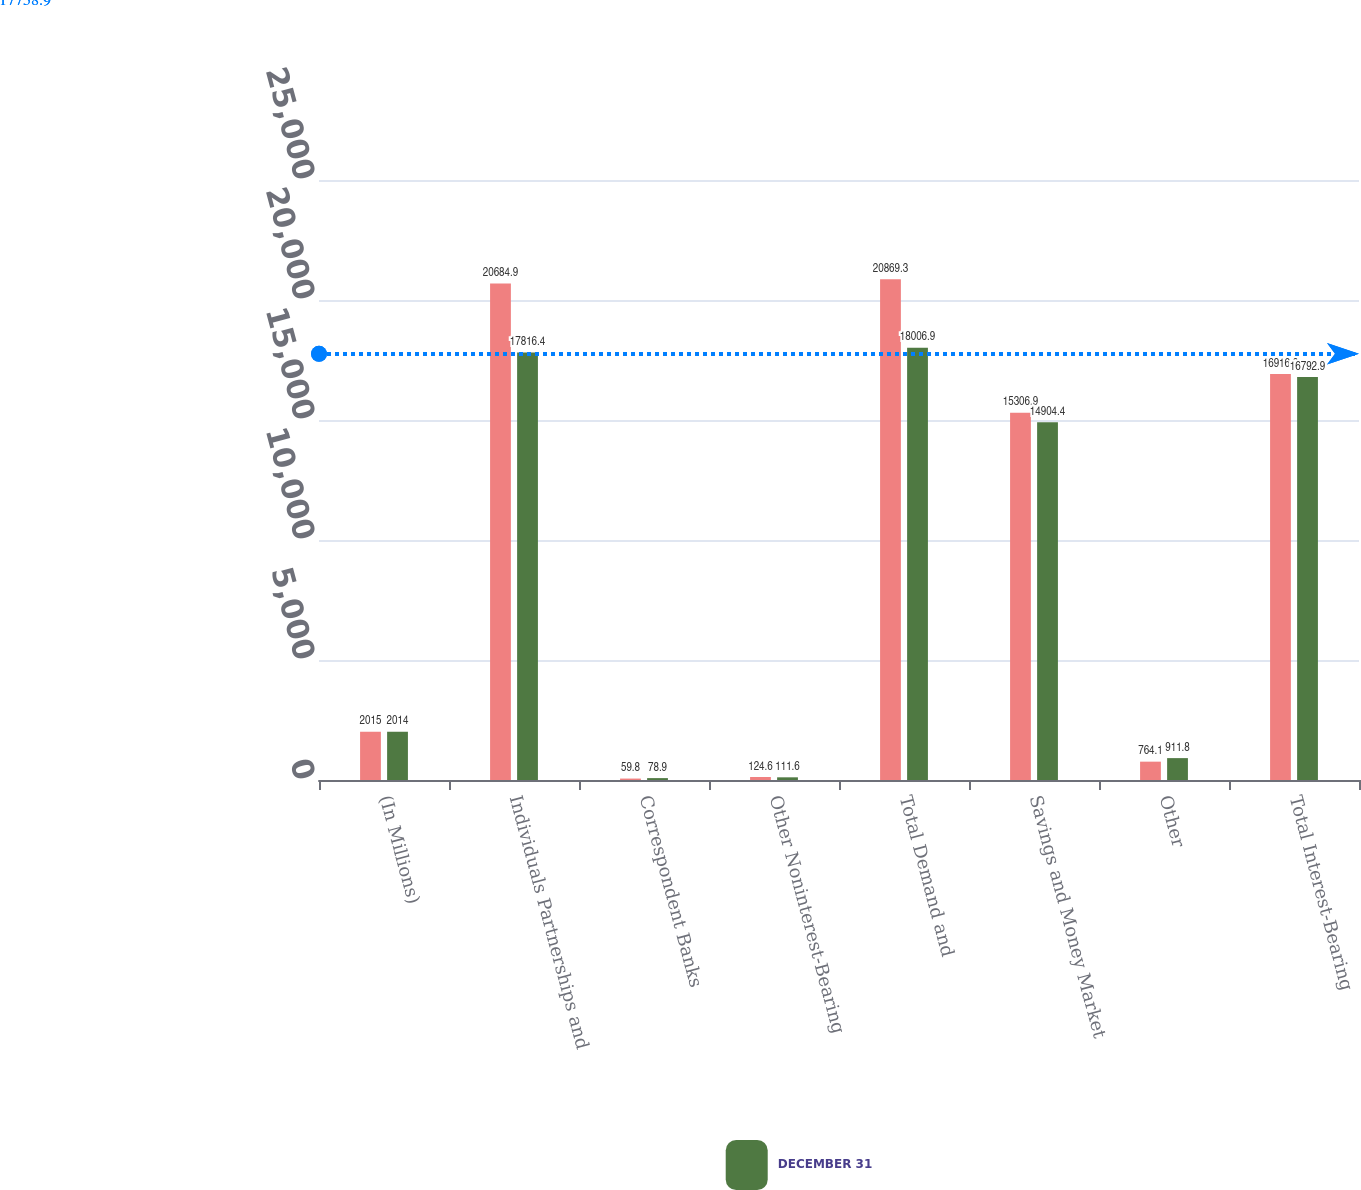<chart> <loc_0><loc_0><loc_500><loc_500><stacked_bar_chart><ecel><fcel>(In Millions)<fcel>Individuals Partnerships and<fcel>Correspondent Banks<fcel>Other Noninterest-Bearing<fcel>Total Demand and<fcel>Savings and Money Market<fcel>Other<fcel>Total Interest-Bearing<nl><fcel>nan<fcel>2015<fcel>20684.9<fcel>59.8<fcel>124.6<fcel>20869.3<fcel>15306.9<fcel>764.1<fcel>16916.8<nl><fcel>DECEMBER 31<fcel>2014<fcel>17816.4<fcel>78.9<fcel>111.6<fcel>18006.9<fcel>14904.4<fcel>911.8<fcel>16792.9<nl></chart> 